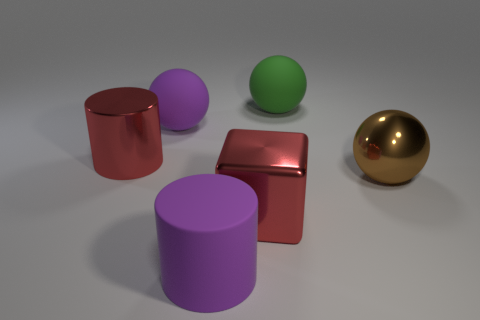There is a large red thing that is to the right of the red object that is left of the big ball that is to the left of the large green thing; what shape is it?
Give a very brief answer. Cube. There is a matte cylinder; is it the same size as the rubber sphere on the right side of the purple cylinder?
Provide a succinct answer. Yes. Is there a matte thing that has the same size as the purple rubber cylinder?
Your answer should be very brief. Yes. What number of other objects are there of the same material as the big brown sphere?
Offer a very short reply. 2. What is the color of the large thing that is both behind the large red cylinder and right of the big purple ball?
Ensure brevity in your answer.  Green. Are the big cylinder behind the red metallic block and the big green ball to the right of the big block made of the same material?
Offer a very short reply. No. Is the color of the metallic cylinder the same as the sphere that is in front of the red cylinder?
Make the answer very short. No. There is a large metallic thing that is the same color as the metallic cylinder; what is its shape?
Give a very brief answer. Cube. Do the metallic cylinder and the big matte cylinder have the same color?
Provide a short and direct response. No. What number of things are big rubber objects to the left of the cube or green matte things?
Keep it short and to the point. 3. 